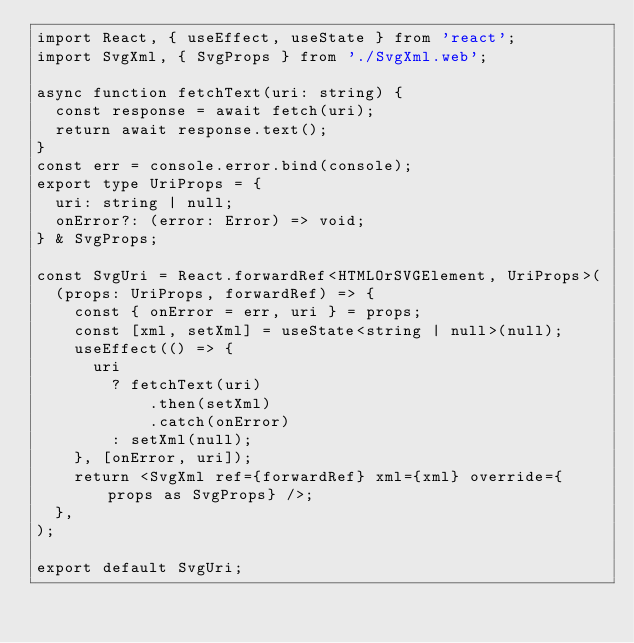<code> <loc_0><loc_0><loc_500><loc_500><_TypeScript_>import React, { useEffect, useState } from 'react';
import SvgXml, { SvgProps } from './SvgXml.web';

async function fetchText(uri: string) {
  const response = await fetch(uri);
  return await response.text();
}
const err = console.error.bind(console);
export type UriProps = {
  uri: string | null;
  onError?: (error: Error) => void;
} & SvgProps;

const SvgUri = React.forwardRef<HTMLOrSVGElement, UriProps>(
  (props: UriProps, forwardRef) => {
    const { onError = err, uri } = props;
    const [xml, setXml] = useState<string | null>(null);
    useEffect(() => {
      uri
        ? fetchText(uri)
            .then(setXml)
            .catch(onError)
        : setXml(null);
    }, [onError, uri]);
    return <SvgXml ref={forwardRef} xml={xml} override={props as SvgProps} />;
  },
);

export default SvgUri;
</code> 